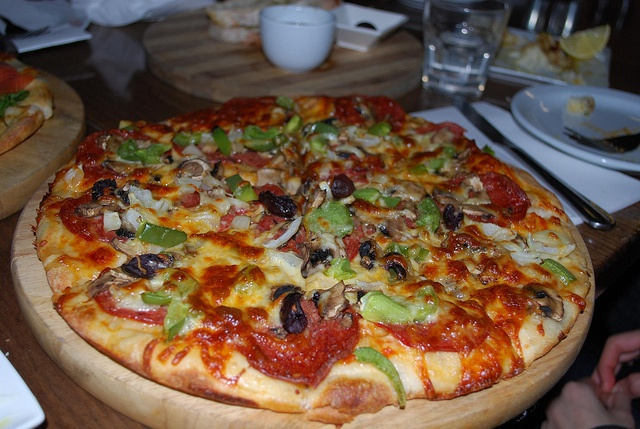Describe the objects in this image and their specific colors. I can see pizza in blue, maroon, brown, olive, and tan tones, cup in blue, gray, black, and darkblue tones, bowl in blue, darkgray, and gray tones, cup in blue, darkgray, and gray tones, and pizza in blue, maroon, black, and gray tones in this image. 